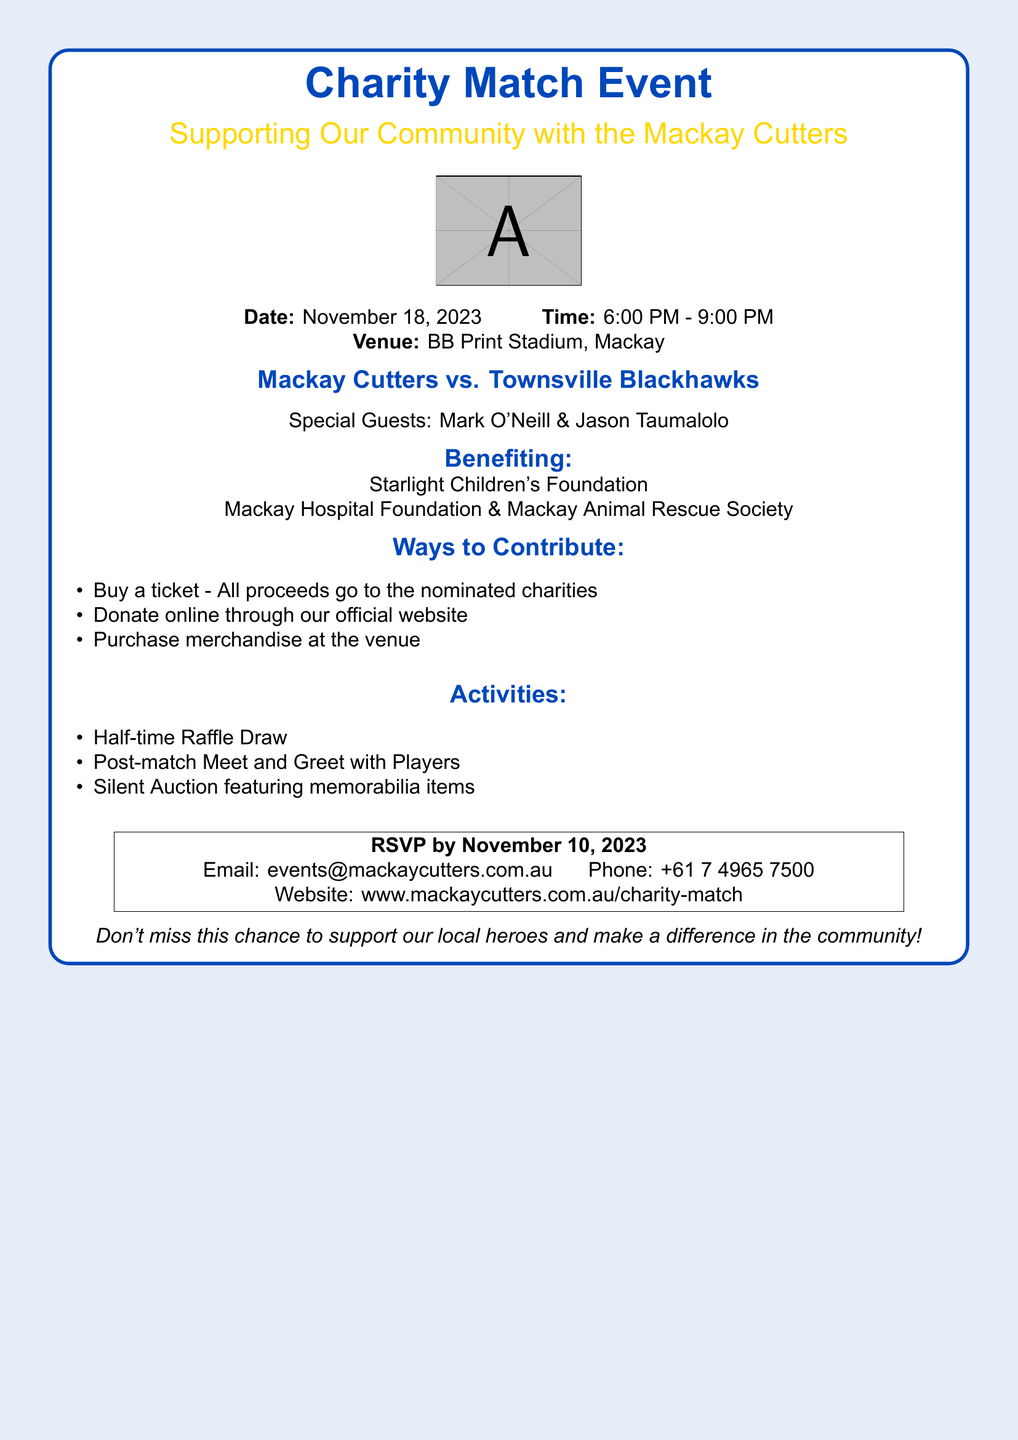What is the date of the event? The date is explicitly mentioned in the document as November 18, 2023.
Answer: November 18, 2023 What time does the event start? The start time is provided in the document as part of the event details.
Answer: 6:00 PM Who are the special guests? The document lists the special guests clearly.
Answer: Mark O'Neill & Jason Taumalolo Which charities will benefit from the event? The document specifies the organizations that will receive the proceeds.
Answer: Starlight Children's Foundation, Mackay Hospital Foundation & Mackay Animal Rescue Society What is one way to contribute to the event? The document lists several ways to contribute, focusing on ticket purchases.
Answer: Buy a ticket How many activities are listed in the document? The document enumerates different activities planned for the event.
Answer: Three What is the RSVP deadline? The document includes a specific date for RSVPs.
Answer: November 10, 2023 How can participants donate online? The document indicates that you can donate through an official website.
Answer: Official website What is the venue for the event? The venue is clearly mentioned in the event details section.
Answer: BB Print Stadium, Mackay 